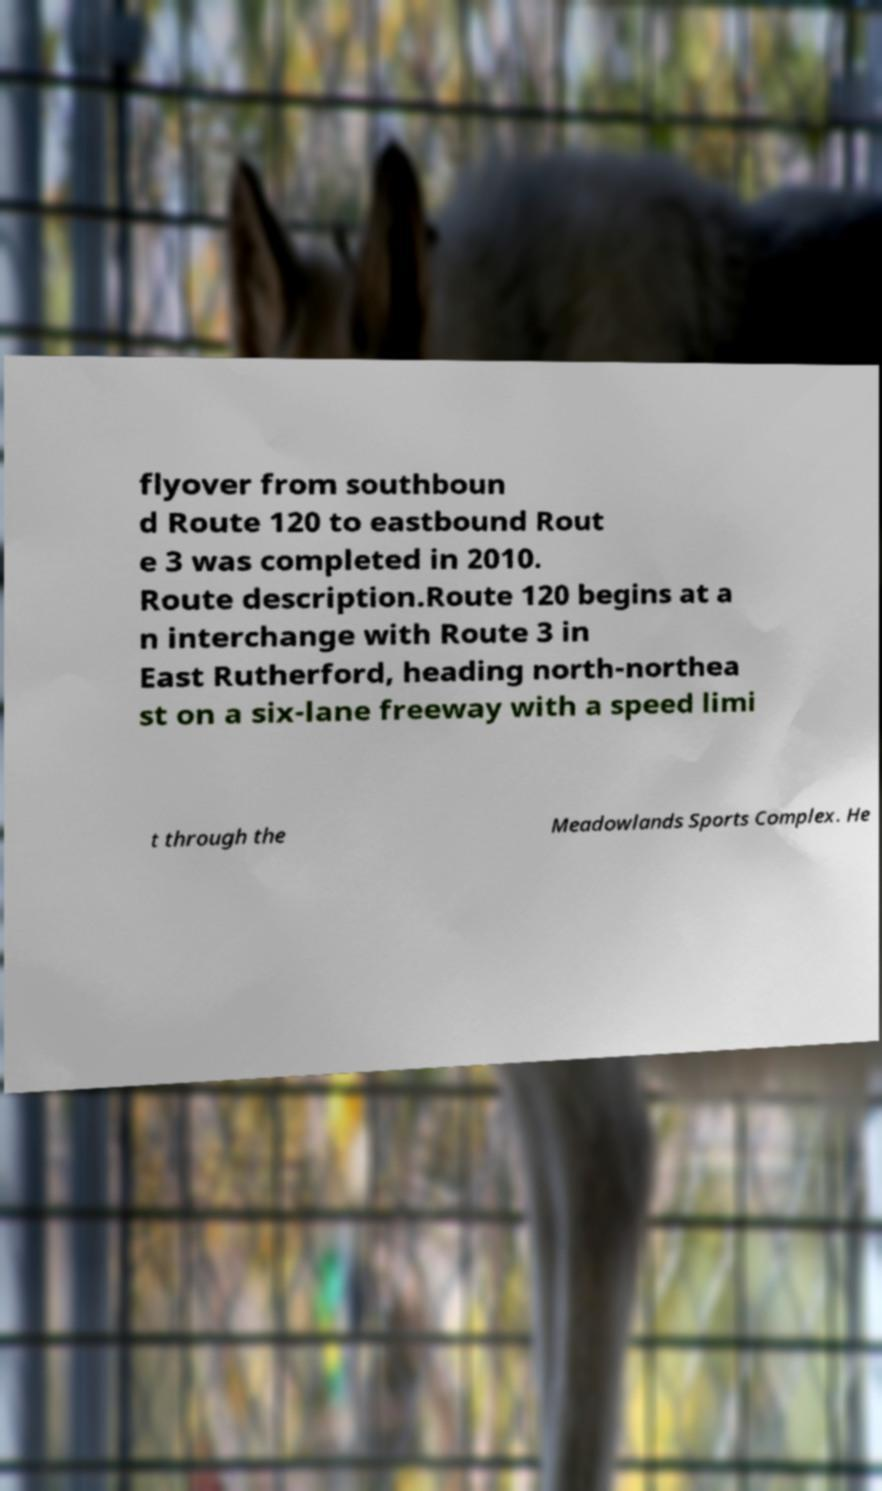What messages or text are displayed in this image? I need them in a readable, typed format. flyover from southboun d Route 120 to eastbound Rout e 3 was completed in 2010. Route description.Route 120 begins at a n interchange with Route 3 in East Rutherford, heading north-northea st on a six-lane freeway with a speed limi t through the Meadowlands Sports Complex. He 